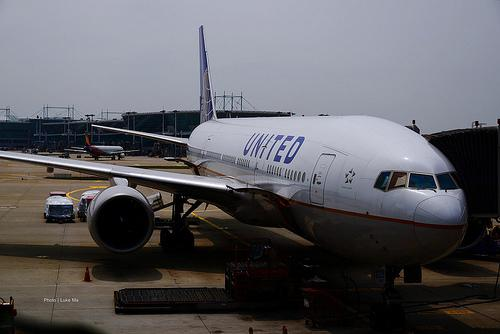Use descriptive language to showcase the scene in the image. A magnificent large white airplane with a vibrant blue and red-colored tail rests gracefully upon a solid cemented airport floor, under a brilliant clear sky. Write a short and simple explanation of what is present in the image. A big white plane with blue stuff on it is on the ground at an airport. Provide a concise and straightforward description of the primary object and related elements in the image. A large white plane with colorful tail and blue writing is parked on a cemented airport floor with a clear sky in the background. Briefly describe the main subject of the image and its environment using casual language. There's a huge white plane with blue letters chilling on the cement ground at an airport, with some vehicles and stuff around it. Describe the image, emphasizing on the airport features visible. An expansive airport scene showcases a large white airplane, surrounded by service vehicles, a solid cemented ground, and a pristine sky backdrop, reflecting a calm day at the airport. Provide a description of the image capturing the transportation aspects. An impressive large white airplane is stationed on an airport runway, surrounded by various service vehicles and equipment, ready for its upcoming flight. Describe the image by highlighting the airplane's features. A white airplane consisting of blue windows, vibrant multicolored tail, and blue lettering is the center of attraction amid an organized airport setting. Give an informative and detailed description of the main object and its surroundings. A white united airplane featuring blue windows and lettering is parked on a brown cemented airport floor, near various vehicles and with a structure visible in the background. Tell a short visual story about the image. Beneath a crystal clear sky, a majestic large white airplane awaits its passengers, as an array of service vehicles diligently work to prepare the flight for a safe and punctual departure. Describe the image by focusing on the color palettes present in the scene. A scene featuring a multitude of colors such as white, blue, red, and brown, portraying a large airplane on a cemented airport floor with vehicles and a backdrop of clear skies. 